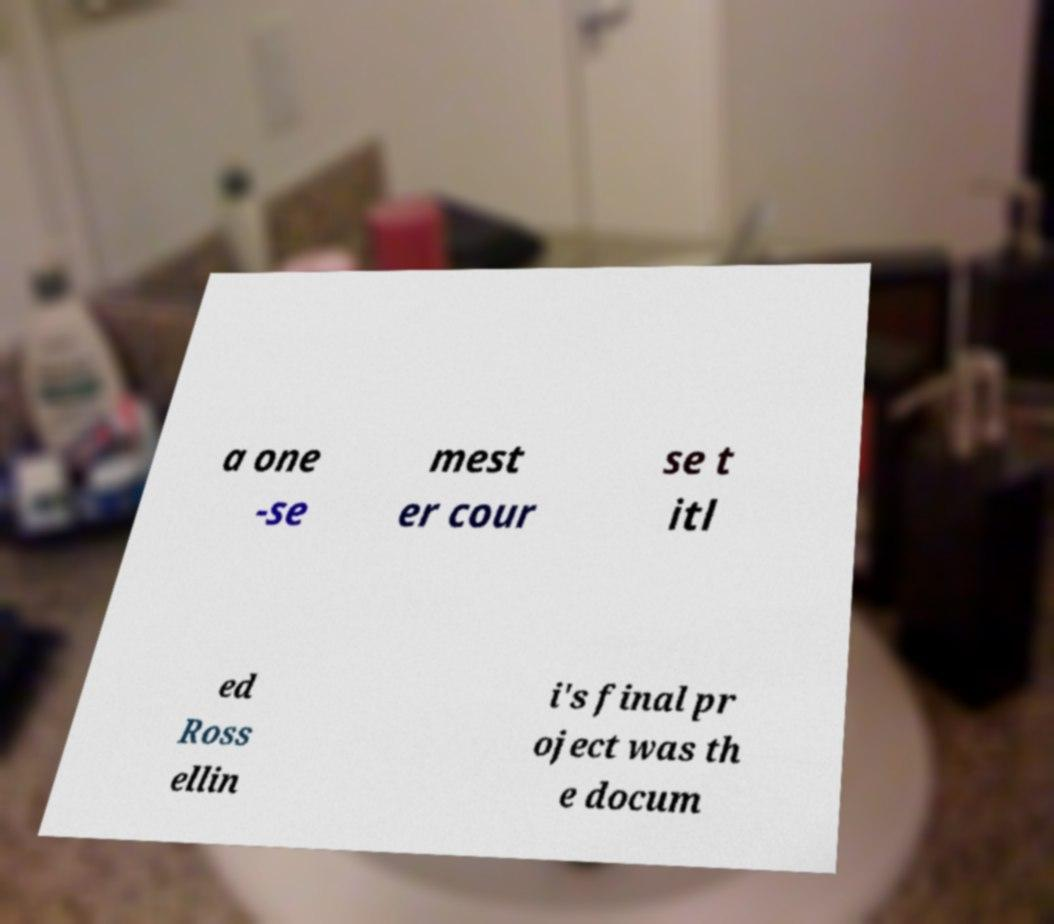Can you read and provide the text displayed in the image?This photo seems to have some interesting text. Can you extract and type it out for me? a one -se mest er cour se t itl ed Ross ellin i's final pr oject was th e docum 